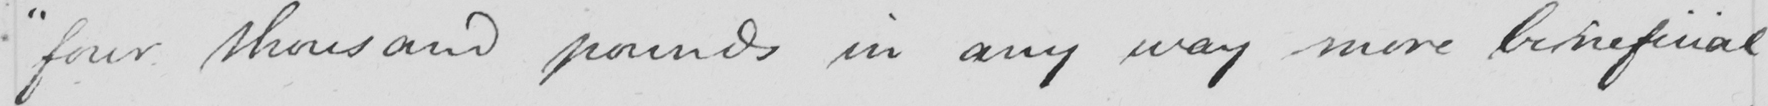Please provide the text content of this handwritten line. " four thousand pounds in any way more beineficial 